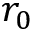Convert formula to latex. <formula><loc_0><loc_0><loc_500><loc_500>r _ { 0 }</formula> 